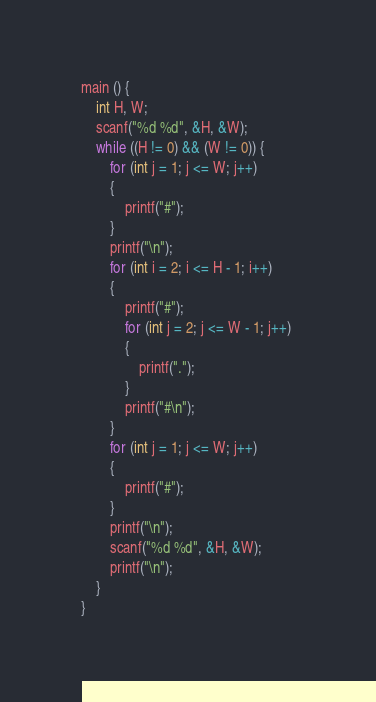<code> <loc_0><loc_0><loc_500><loc_500><_C_>main () {
    int H, W;
    scanf("%d %d", &H, &W);
    while ((H != 0) && (W != 0)) {
        for (int j = 1; j <= W; j++) 
        {
            printf("#");
        }
        printf("\n");
        for (int i = 2; i <= H - 1; i++) 
        {
            printf("#");
            for (int j = 2; j <= W - 1; j++) 
            {
                printf(".");
            }
            printf("#\n");
        }
        for (int j = 1; j <= W; j++) 
        {
            printf("#");
        }
        printf("\n");
        scanf("%d %d", &H, &W);
        printf("\n");
    }
}
</code> 